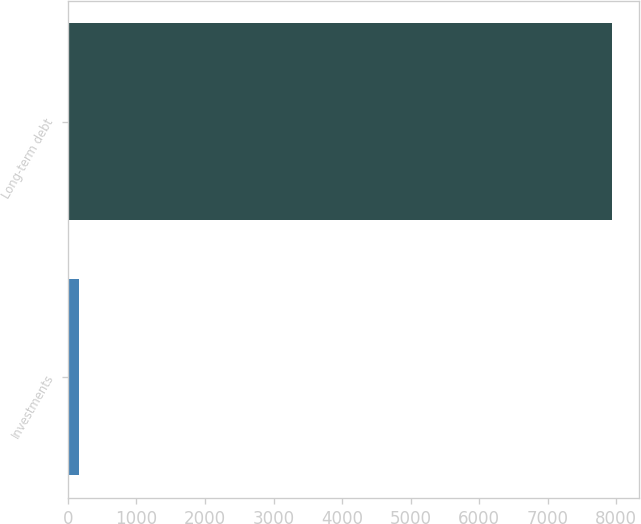<chart> <loc_0><loc_0><loc_500><loc_500><bar_chart><fcel>Investments<fcel>Long-term debt<nl><fcel>160<fcel>7934<nl></chart> 